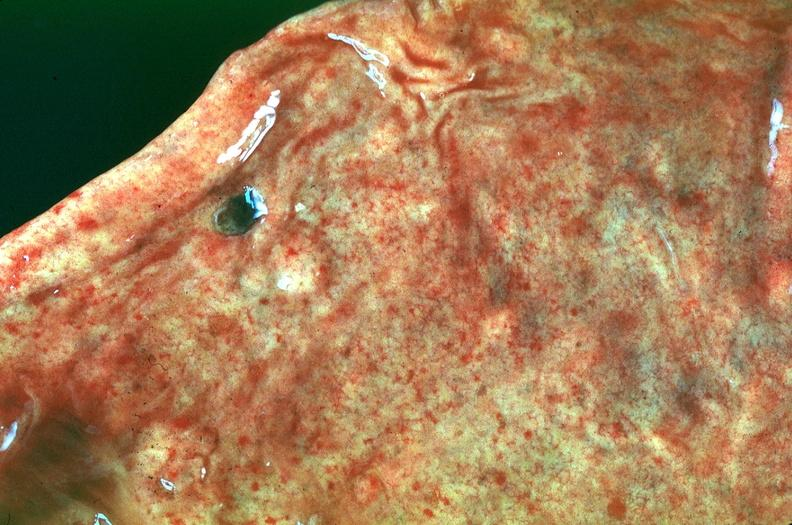what is present?
Answer the question using a single word or phrase. Gastrointestinal 